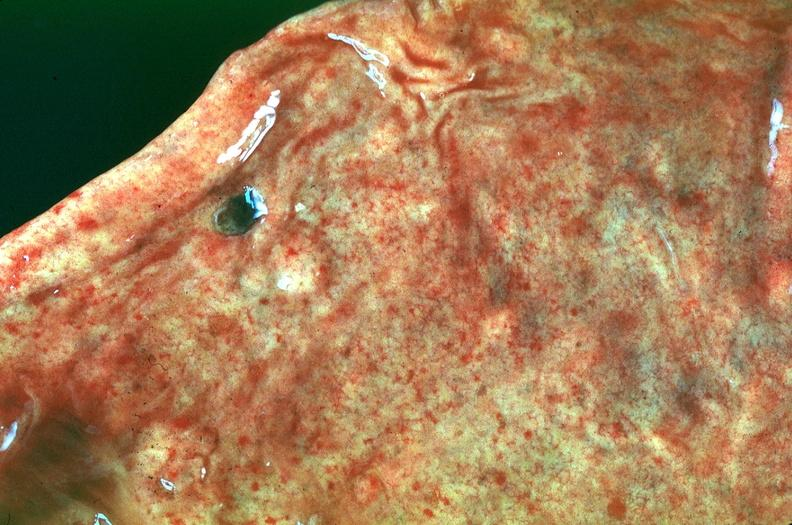what is present?
Answer the question using a single word or phrase. Gastrointestinal 